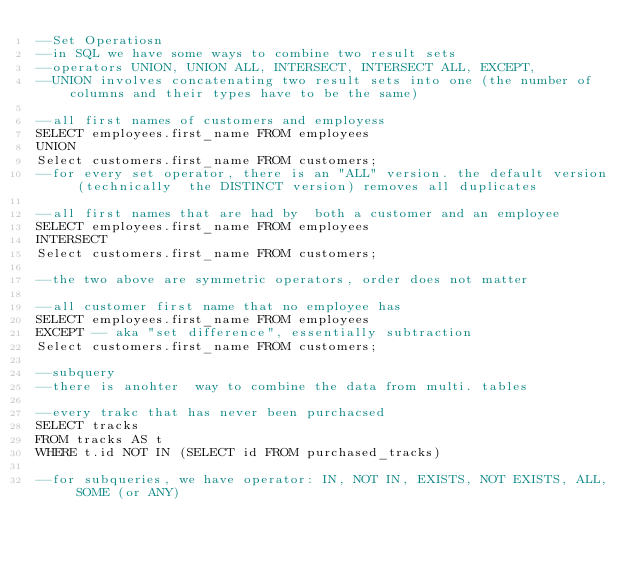<code> <loc_0><loc_0><loc_500><loc_500><_SQL_>--Set Operatiosn
--in SQL we have some ways to combine two result sets
--operators UNION, UNION ALL, INTERSECT, INTERSECT ALL, EXCEPT,
--UNION involves concatenating two result sets into one (the number of columns and their types have to be the same)

--all first names of customers and employess
SELECT employees.first_name FROM employees
UNION
Select customers.first_name FROM customers;
--for every set operator, there is an "ALL" version. the default version (technically  the DISTINCT version) removes all duplicates

--all first names that are had by  both a customer and an employee
SELECT employees.first_name FROM employees
INTERSECT
Select customers.first_name FROM customers;

--the two above are symmetric operators, order does not matter

--all customer first name that no employee has
SELECT employees.first_name FROM employees
EXCEPT -- aka "set difference", essentially subtraction
Select customers.first_name FROM customers;

--subquery
--there is anohter  way to combine the data from multi. tables

--every trakc that has never been purchacsed
SELECT tracks
FROM tracks AS t
WHERE t.id NOT IN (SELECT id FROM purchased_tracks)

--for subqueries, we have operator: IN, NOT IN, EXISTS, NOT EXISTS, ALL, SOME (or ANY)</code> 